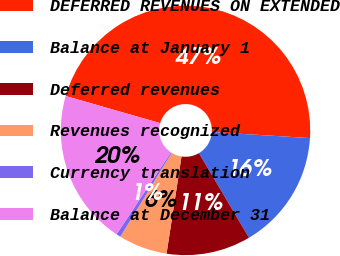<chart> <loc_0><loc_0><loc_500><loc_500><pie_chart><fcel>DEFERRED REVENUES ON EXTENDED<fcel>Balance at January 1<fcel>Deferred revenues<fcel>Revenues recognized<fcel>Currency translation<fcel>Balance at December 31<nl><fcel>46.53%<fcel>15.52%<fcel>10.93%<fcel>6.33%<fcel>0.57%<fcel>20.12%<nl></chart> 